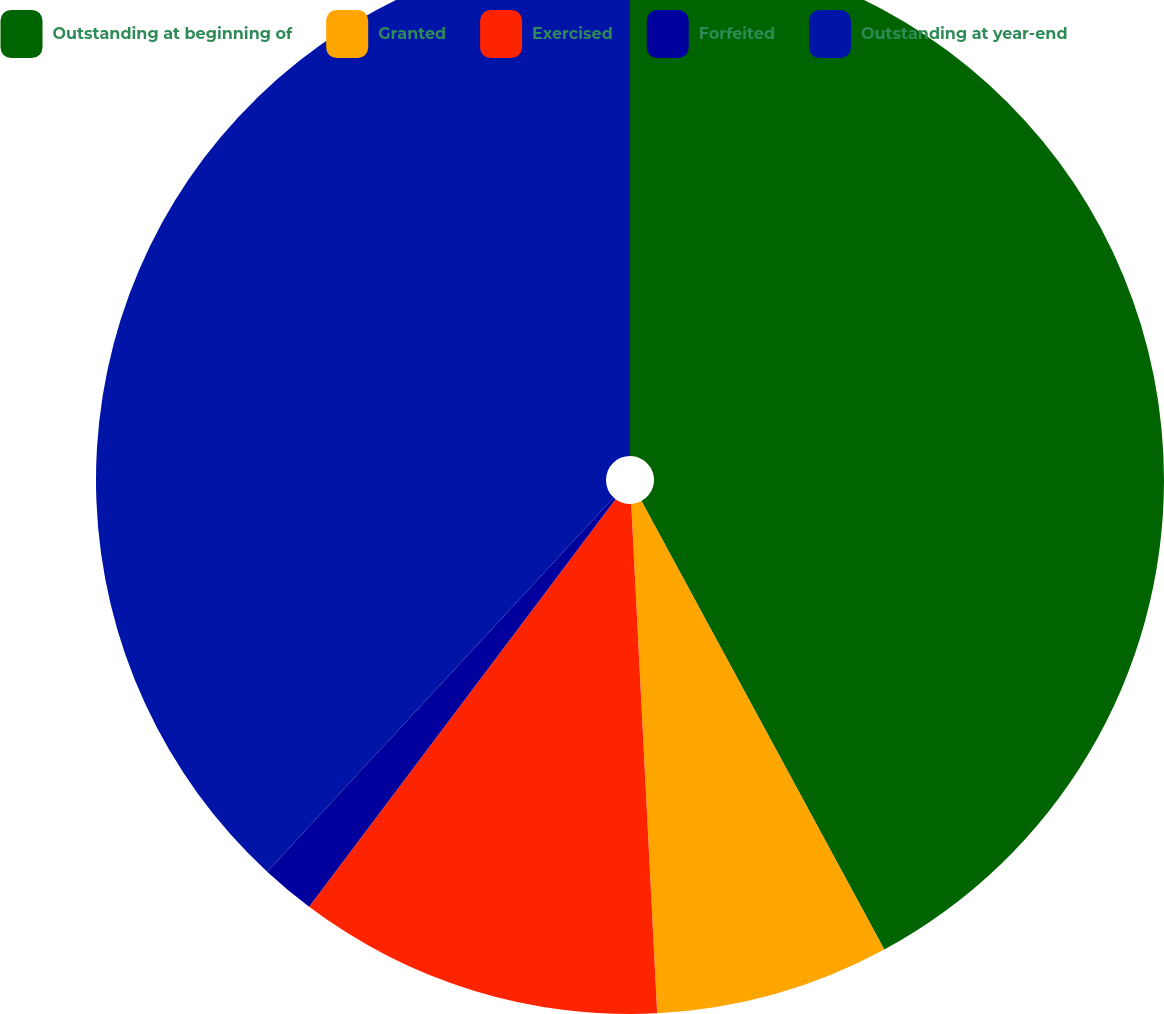<chart> <loc_0><loc_0><loc_500><loc_500><pie_chart><fcel>Outstanding at beginning of<fcel>Granted<fcel>Exercised<fcel>Forfeited<fcel>Outstanding at year-end<nl><fcel>42.1%<fcel>7.09%<fcel>11.07%<fcel>1.63%<fcel>38.11%<nl></chart> 